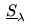<formula> <loc_0><loc_0><loc_500><loc_500>\underline { S } _ { \lambda }</formula> 